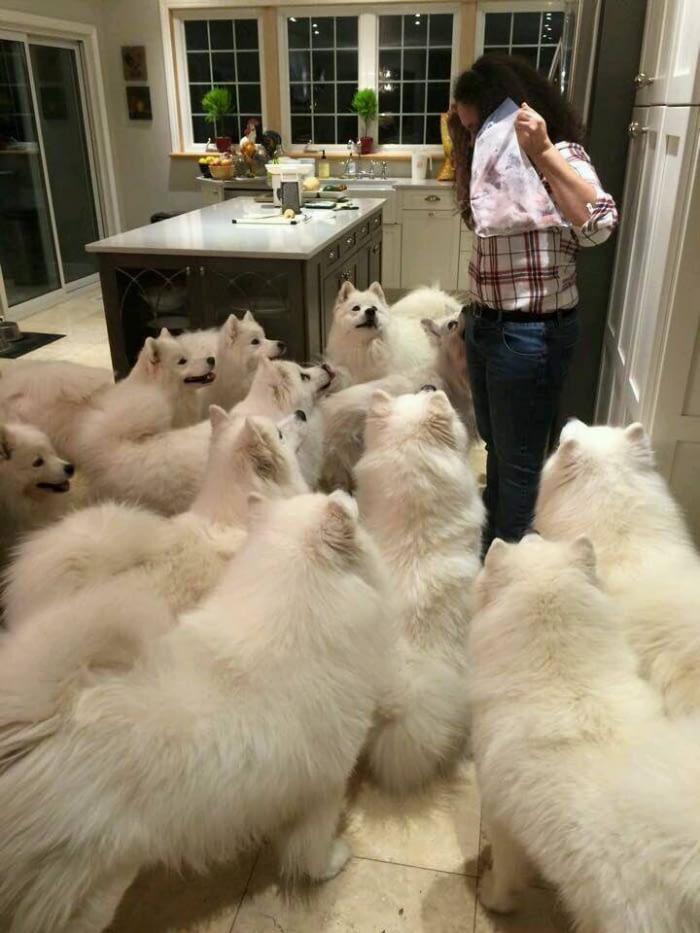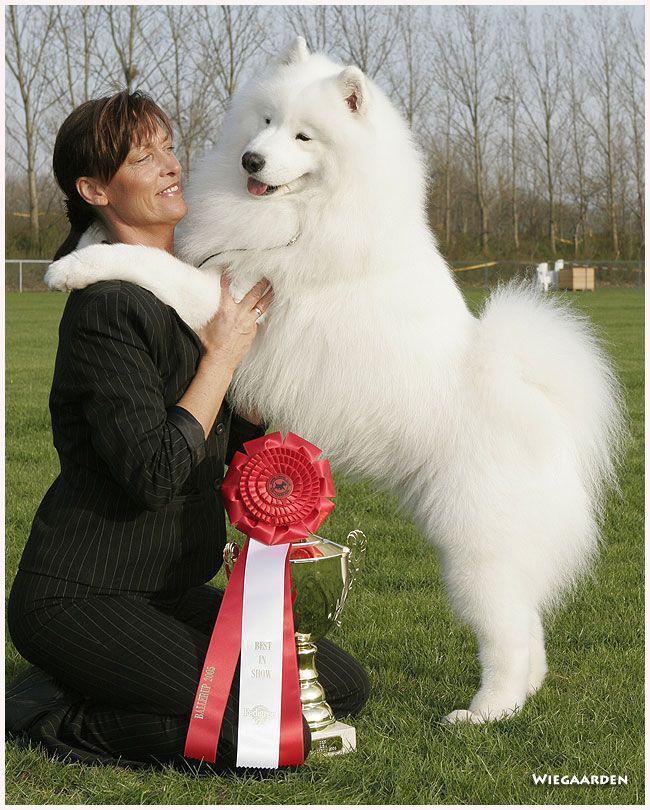The first image is the image on the left, the second image is the image on the right. Analyze the images presented: Is the assertion "There are two dogs." valid? Answer yes or no. No. The first image is the image on the left, the second image is the image on the right. Evaluate the accuracy of this statement regarding the images: "there are two dogs in the image pair". Is it true? Answer yes or no. No. 